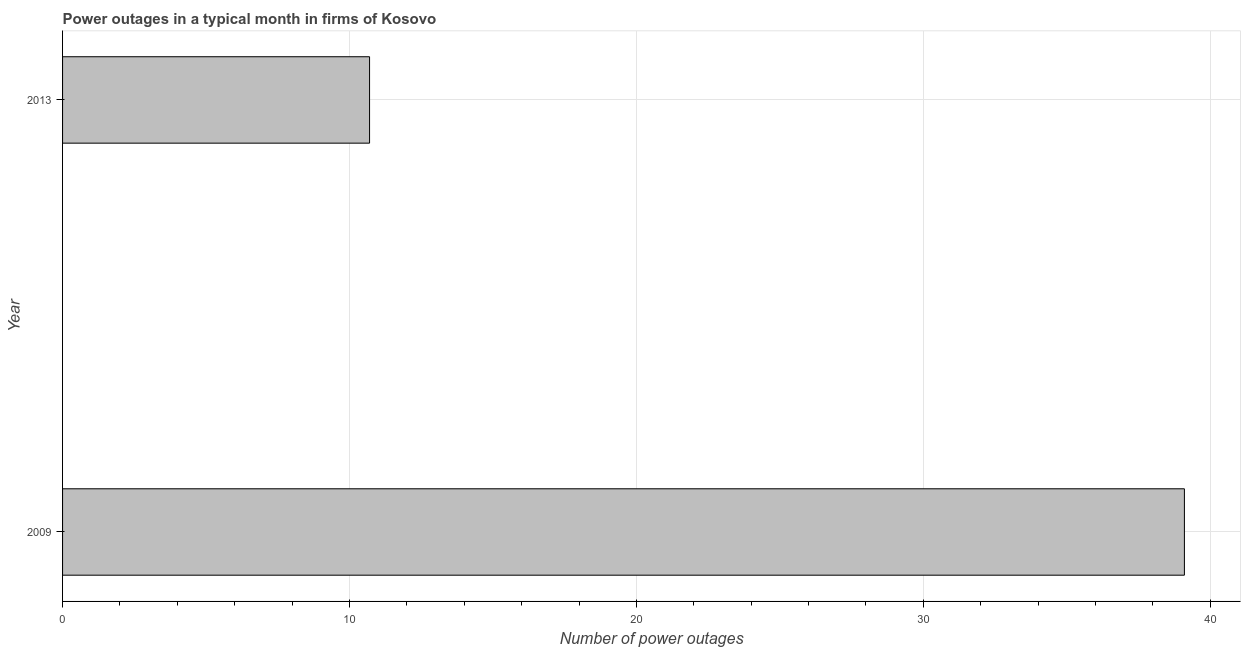Does the graph contain any zero values?
Keep it short and to the point. No. Does the graph contain grids?
Provide a short and direct response. Yes. What is the title of the graph?
Ensure brevity in your answer.  Power outages in a typical month in firms of Kosovo. What is the label or title of the X-axis?
Offer a very short reply. Number of power outages. What is the label or title of the Y-axis?
Make the answer very short. Year. Across all years, what is the maximum number of power outages?
Your response must be concise. 39.1. What is the sum of the number of power outages?
Your response must be concise. 49.8. What is the difference between the number of power outages in 2009 and 2013?
Keep it short and to the point. 28.4. What is the average number of power outages per year?
Offer a terse response. 24.9. What is the median number of power outages?
Ensure brevity in your answer.  24.9. What is the ratio of the number of power outages in 2009 to that in 2013?
Give a very brief answer. 3.65. In how many years, is the number of power outages greater than the average number of power outages taken over all years?
Provide a succinct answer. 1. How many bars are there?
Give a very brief answer. 2. What is the Number of power outages in 2009?
Keep it short and to the point. 39.1. What is the difference between the Number of power outages in 2009 and 2013?
Provide a succinct answer. 28.4. What is the ratio of the Number of power outages in 2009 to that in 2013?
Make the answer very short. 3.65. 